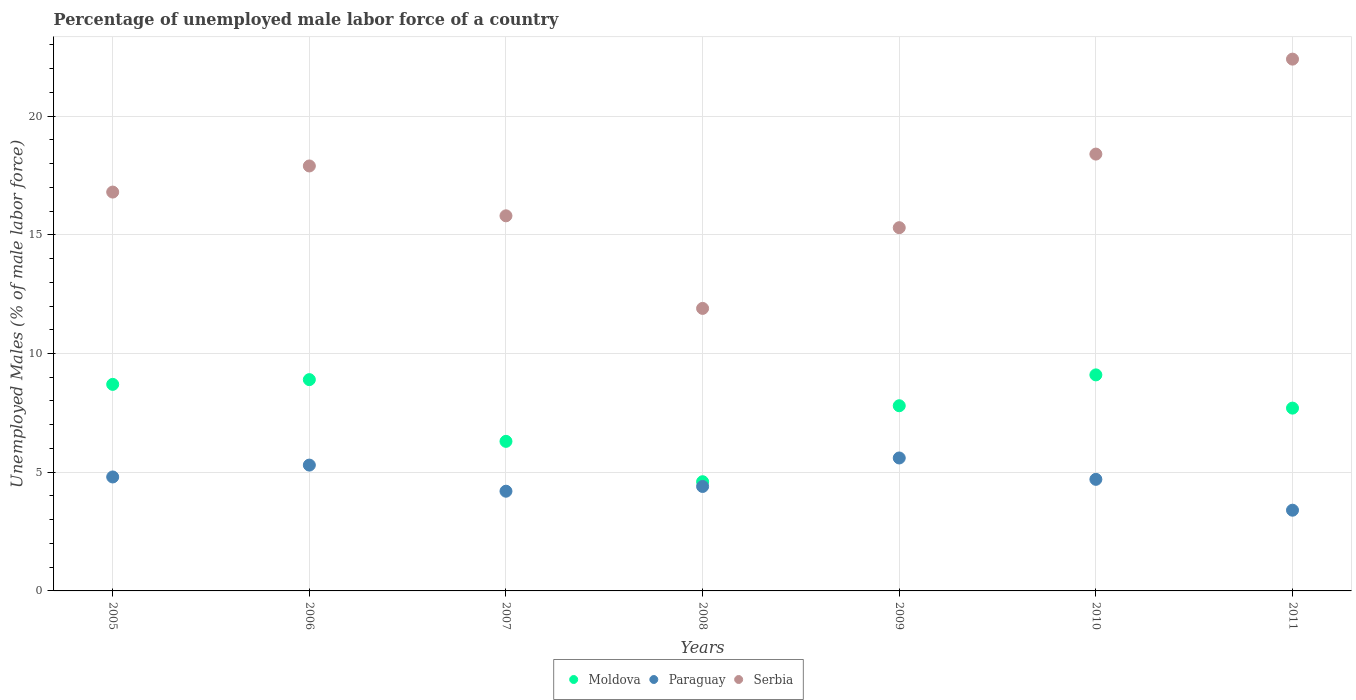Is the number of dotlines equal to the number of legend labels?
Ensure brevity in your answer.  Yes. What is the percentage of unemployed male labor force in Paraguay in 2007?
Make the answer very short. 4.2. Across all years, what is the maximum percentage of unemployed male labor force in Moldova?
Provide a short and direct response. 9.1. Across all years, what is the minimum percentage of unemployed male labor force in Serbia?
Ensure brevity in your answer.  11.9. In which year was the percentage of unemployed male labor force in Paraguay maximum?
Provide a short and direct response. 2009. In which year was the percentage of unemployed male labor force in Serbia minimum?
Make the answer very short. 2008. What is the total percentage of unemployed male labor force in Moldova in the graph?
Offer a very short reply. 53.1. What is the difference between the percentage of unemployed male labor force in Serbia in 2009 and that in 2011?
Your answer should be compact. -7.1. What is the difference between the percentage of unemployed male labor force in Paraguay in 2011 and the percentage of unemployed male labor force in Serbia in 2005?
Keep it short and to the point. -13.4. What is the average percentage of unemployed male labor force in Paraguay per year?
Offer a very short reply. 4.63. In the year 2010, what is the difference between the percentage of unemployed male labor force in Serbia and percentage of unemployed male labor force in Moldova?
Offer a terse response. 9.3. What is the ratio of the percentage of unemployed male labor force in Paraguay in 2008 to that in 2011?
Your answer should be very brief. 1.29. What is the difference between the highest and the second highest percentage of unemployed male labor force in Moldova?
Provide a short and direct response. 0.2. What is the difference between the highest and the lowest percentage of unemployed male labor force in Moldova?
Make the answer very short. 4.5. Is the sum of the percentage of unemployed male labor force in Paraguay in 2009 and 2011 greater than the maximum percentage of unemployed male labor force in Moldova across all years?
Offer a terse response. No. Is it the case that in every year, the sum of the percentage of unemployed male labor force in Serbia and percentage of unemployed male labor force in Moldova  is greater than the percentage of unemployed male labor force in Paraguay?
Your answer should be very brief. Yes. Does the percentage of unemployed male labor force in Serbia monotonically increase over the years?
Offer a very short reply. No. What is the difference between two consecutive major ticks on the Y-axis?
Give a very brief answer. 5. Does the graph contain grids?
Keep it short and to the point. Yes. How many legend labels are there?
Keep it short and to the point. 3. What is the title of the graph?
Provide a short and direct response. Percentage of unemployed male labor force of a country. Does "North America" appear as one of the legend labels in the graph?
Ensure brevity in your answer.  No. What is the label or title of the X-axis?
Keep it short and to the point. Years. What is the label or title of the Y-axis?
Keep it short and to the point. Unemployed Males (% of male labor force). What is the Unemployed Males (% of male labor force) in Moldova in 2005?
Your answer should be compact. 8.7. What is the Unemployed Males (% of male labor force) of Paraguay in 2005?
Your response must be concise. 4.8. What is the Unemployed Males (% of male labor force) of Serbia in 2005?
Ensure brevity in your answer.  16.8. What is the Unemployed Males (% of male labor force) in Moldova in 2006?
Make the answer very short. 8.9. What is the Unemployed Males (% of male labor force) in Paraguay in 2006?
Ensure brevity in your answer.  5.3. What is the Unemployed Males (% of male labor force) in Serbia in 2006?
Provide a short and direct response. 17.9. What is the Unemployed Males (% of male labor force) of Moldova in 2007?
Provide a succinct answer. 6.3. What is the Unemployed Males (% of male labor force) in Paraguay in 2007?
Offer a terse response. 4.2. What is the Unemployed Males (% of male labor force) in Serbia in 2007?
Provide a short and direct response. 15.8. What is the Unemployed Males (% of male labor force) in Moldova in 2008?
Your answer should be very brief. 4.6. What is the Unemployed Males (% of male labor force) of Paraguay in 2008?
Provide a succinct answer. 4.4. What is the Unemployed Males (% of male labor force) in Serbia in 2008?
Ensure brevity in your answer.  11.9. What is the Unemployed Males (% of male labor force) of Moldova in 2009?
Your answer should be very brief. 7.8. What is the Unemployed Males (% of male labor force) of Paraguay in 2009?
Keep it short and to the point. 5.6. What is the Unemployed Males (% of male labor force) of Serbia in 2009?
Give a very brief answer. 15.3. What is the Unemployed Males (% of male labor force) in Moldova in 2010?
Offer a very short reply. 9.1. What is the Unemployed Males (% of male labor force) of Paraguay in 2010?
Give a very brief answer. 4.7. What is the Unemployed Males (% of male labor force) of Serbia in 2010?
Your response must be concise. 18.4. What is the Unemployed Males (% of male labor force) in Moldova in 2011?
Ensure brevity in your answer.  7.7. What is the Unemployed Males (% of male labor force) in Paraguay in 2011?
Provide a short and direct response. 3.4. What is the Unemployed Males (% of male labor force) of Serbia in 2011?
Provide a short and direct response. 22.4. Across all years, what is the maximum Unemployed Males (% of male labor force) of Moldova?
Offer a very short reply. 9.1. Across all years, what is the maximum Unemployed Males (% of male labor force) in Paraguay?
Keep it short and to the point. 5.6. Across all years, what is the maximum Unemployed Males (% of male labor force) of Serbia?
Your response must be concise. 22.4. Across all years, what is the minimum Unemployed Males (% of male labor force) of Moldova?
Your answer should be very brief. 4.6. Across all years, what is the minimum Unemployed Males (% of male labor force) of Paraguay?
Provide a short and direct response. 3.4. Across all years, what is the minimum Unemployed Males (% of male labor force) in Serbia?
Give a very brief answer. 11.9. What is the total Unemployed Males (% of male labor force) of Moldova in the graph?
Keep it short and to the point. 53.1. What is the total Unemployed Males (% of male labor force) in Paraguay in the graph?
Keep it short and to the point. 32.4. What is the total Unemployed Males (% of male labor force) of Serbia in the graph?
Offer a terse response. 118.5. What is the difference between the Unemployed Males (% of male labor force) of Paraguay in 2005 and that in 2007?
Your answer should be compact. 0.6. What is the difference between the Unemployed Males (% of male labor force) in Paraguay in 2005 and that in 2008?
Offer a terse response. 0.4. What is the difference between the Unemployed Males (% of male labor force) in Moldova in 2005 and that in 2009?
Give a very brief answer. 0.9. What is the difference between the Unemployed Males (% of male labor force) in Serbia in 2005 and that in 2009?
Provide a short and direct response. 1.5. What is the difference between the Unemployed Males (% of male labor force) of Paraguay in 2005 and that in 2010?
Offer a terse response. 0.1. What is the difference between the Unemployed Males (% of male labor force) in Serbia in 2005 and that in 2010?
Provide a succinct answer. -1.6. What is the difference between the Unemployed Males (% of male labor force) in Moldova in 2005 and that in 2011?
Your response must be concise. 1. What is the difference between the Unemployed Males (% of male labor force) in Paraguay in 2005 and that in 2011?
Your answer should be compact. 1.4. What is the difference between the Unemployed Males (% of male labor force) in Serbia in 2005 and that in 2011?
Your answer should be very brief. -5.6. What is the difference between the Unemployed Males (% of male labor force) of Moldova in 2006 and that in 2007?
Provide a succinct answer. 2.6. What is the difference between the Unemployed Males (% of male labor force) of Paraguay in 2006 and that in 2007?
Your response must be concise. 1.1. What is the difference between the Unemployed Males (% of male labor force) in Moldova in 2006 and that in 2008?
Your answer should be compact. 4.3. What is the difference between the Unemployed Males (% of male labor force) in Serbia in 2006 and that in 2008?
Give a very brief answer. 6. What is the difference between the Unemployed Males (% of male labor force) in Moldova in 2006 and that in 2009?
Give a very brief answer. 1.1. What is the difference between the Unemployed Males (% of male labor force) in Moldova in 2006 and that in 2010?
Your answer should be very brief. -0.2. What is the difference between the Unemployed Males (% of male labor force) of Paraguay in 2006 and that in 2010?
Make the answer very short. 0.6. What is the difference between the Unemployed Males (% of male labor force) in Serbia in 2006 and that in 2011?
Offer a very short reply. -4.5. What is the difference between the Unemployed Males (% of male labor force) of Moldova in 2007 and that in 2009?
Ensure brevity in your answer.  -1.5. What is the difference between the Unemployed Males (% of male labor force) in Paraguay in 2007 and that in 2009?
Your answer should be compact. -1.4. What is the difference between the Unemployed Males (% of male labor force) in Moldova in 2007 and that in 2010?
Provide a succinct answer. -2.8. What is the difference between the Unemployed Males (% of male labor force) of Serbia in 2007 and that in 2010?
Your answer should be compact. -2.6. What is the difference between the Unemployed Males (% of male labor force) in Paraguay in 2007 and that in 2011?
Offer a terse response. 0.8. What is the difference between the Unemployed Males (% of male labor force) of Serbia in 2007 and that in 2011?
Provide a short and direct response. -6.6. What is the difference between the Unemployed Males (% of male labor force) of Paraguay in 2008 and that in 2009?
Your answer should be compact. -1.2. What is the difference between the Unemployed Males (% of male labor force) of Moldova in 2008 and that in 2010?
Provide a short and direct response. -4.5. What is the difference between the Unemployed Males (% of male labor force) in Paraguay in 2008 and that in 2010?
Your answer should be very brief. -0.3. What is the difference between the Unemployed Males (% of male labor force) in Serbia in 2008 and that in 2010?
Provide a short and direct response. -6.5. What is the difference between the Unemployed Males (% of male labor force) of Paraguay in 2008 and that in 2011?
Your answer should be compact. 1. What is the difference between the Unemployed Males (% of male labor force) in Serbia in 2008 and that in 2011?
Your answer should be very brief. -10.5. What is the difference between the Unemployed Males (% of male labor force) of Moldova in 2009 and that in 2010?
Give a very brief answer. -1.3. What is the difference between the Unemployed Males (% of male labor force) of Paraguay in 2009 and that in 2010?
Your response must be concise. 0.9. What is the difference between the Unemployed Males (% of male labor force) of Paraguay in 2009 and that in 2011?
Your response must be concise. 2.2. What is the difference between the Unemployed Males (% of male labor force) in Serbia in 2009 and that in 2011?
Ensure brevity in your answer.  -7.1. What is the difference between the Unemployed Males (% of male labor force) of Moldova in 2010 and that in 2011?
Provide a short and direct response. 1.4. What is the difference between the Unemployed Males (% of male labor force) in Paraguay in 2010 and that in 2011?
Make the answer very short. 1.3. What is the difference between the Unemployed Males (% of male labor force) of Serbia in 2010 and that in 2011?
Give a very brief answer. -4. What is the difference between the Unemployed Males (% of male labor force) of Moldova in 2005 and the Unemployed Males (% of male labor force) of Paraguay in 2006?
Offer a terse response. 3.4. What is the difference between the Unemployed Males (% of male labor force) of Moldova in 2005 and the Unemployed Males (% of male labor force) of Serbia in 2006?
Your response must be concise. -9.2. What is the difference between the Unemployed Males (% of male labor force) in Paraguay in 2005 and the Unemployed Males (% of male labor force) in Serbia in 2006?
Your answer should be compact. -13.1. What is the difference between the Unemployed Males (% of male labor force) of Moldova in 2005 and the Unemployed Males (% of male labor force) of Serbia in 2007?
Provide a succinct answer. -7.1. What is the difference between the Unemployed Males (% of male labor force) in Paraguay in 2005 and the Unemployed Males (% of male labor force) in Serbia in 2007?
Make the answer very short. -11. What is the difference between the Unemployed Males (% of male labor force) of Moldova in 2005 and the Unemployed Males (% of male labor force) of Paraguay in 2008?
Provide a short and direct response. 4.3. What is the difference between the Unemployed Males (% of male labor force) in Moldova in 2005 and the Unemployed Males (% of male labor force) in Paraguay in 2009?
Offer a very short reply. 3.1. What is the difference between the Unemployed Males (% of male labor force) of Moldova in 2005 and the Unemployed Males (% of male labor force) of Serbia in 2009?
Make the answer very short. -6.6. What is the difference between the Unemployed Males (% of male labor force) of Paraguay in 2005 and the Unemployed Males (% of male labor force) of Serbia in 2009?
Your response must be concise. -10.5. What is the difference between the Unemployed Males (% of male labor force) in Moldova in 2005 and the Unemployed Males (% of male labor force) in Serbia in 2010?
Give a very brief answer. -9.7. What is the difference between the Unemployed Males (% of male labor force) in Paraguay in 2005 and the Unemployed Males (% of male labor force) in Serbia in 2010?
Your response must be concise. -13.6. What is the difference between the Unemployed Males (% of male labor force) of Moldova in 2005 and the Unemployed Males (% of male labor force) of Serbia in 2011?
Offer a terse response. -13.7. What is the difference between the Unemployed Males (% of male labor force) in Paraguay in 2005 and the Unemployed Males (% of male labor force) in Serbia in 2011?
Your answer should be very brief. -17.6. What is the difference between the Unemployed Males (% of male labor force) in Moldova in 2006 and the Unemployed Males (% of male labor force) in Serbia in 2007?
Keep it short and to the point. -6.9. What is the difference between the Unemployed Males (% of male labor force) in Moldova in 2006 and the Unemployed Males (% of male labor force) in Paraguay in 2008?
Offer a very short reply. 4.5. What is the difference between the Unemployed Males (% of male labor force) of Moldova in 2006 and the Unemployed Males (% of male labor force) of Serbia in 2008?
Offer a terse response. -3. What is the difference between the Unemployed Males (% of male labor force) of Paraguay in 2006 and the Unemployed Males (% of male labor force) of Serbia in 2008?
Ensure brevity in your answer.  -6.6. What is the difference between the Unemployed Males (% of male labor force) of Moldova in 2006 and the Unemployed Males (% of male labor force) of Paraguay in 2009?
Your answer should be very brief. 3.3. What is the difference between the Unemployed Males (% of male labor force) of Paraguay in 2006 and the Unemployed Males (% of male labor force) of Serbia in 2010?
Your response must be concise. -13.1. What is the difference between the Unemployed Males (% of male labor force) of Moldova in 2006 and the Unemployed Males (% of male labor force) of Paraguay in 2011?
Your answer should be compact. 5.5. What is the difference between the Unemployed Males (% of male labor force) in Paraguay in 2006 and the Unemployed Males (% of male labor force) in Serbia in 2011?
Offer a terse response. -17.1. What is the difference between the Unemployed Males (% of male labor force) of Moldova in 2007 and the Unemployed Males (% of male labor force) of Serbia in 2008?
Your answer should be very brief. -5.6. What is the difference between the Unemployed Males (% of male labor force) of Paraguay in 2007 and the Unemployed Males (% of male labor force) of Serbia in 2009?
Your response must be concise. -11.1. What is the difference between the Unemployed Males (% of male labor force) in Moldova in 2007 and the Unemployed Males (% of male labor force) in Paraguay in 2010?
Your answer should be very brief. 1.6. What is the difference between the Unemployed Males (% of male labor force) in Moldova in 2007 and the Unemployed Males (% of male labor force) in Serbia in 2011?
Provide a succinct answer. -16.1. What is the difference between the Unemployed Males (% of male labor force) of Paraguay in 2007 and the Unemployed Males (% of male labor force) of Serbia in 2011?
Provide a succinct answer. -18.2. What is the difference between the Unemployed Males (% of male labor force) of Moldova in 2008 and the Unemployed Males (% of male labor force) of Paraguay in 2009?
Ensure brevity in your answer.  -1. What is the difference between the Unemployed Males (% of male labor force) of Paraguay in 2008 and the Unemployed Males (% of male labor force) of Serbia in 2009?
Give a very brief answer. -10.9. What is the difference between the Unemployed Males (% of male labor force) in Moldova in 2008 and the Unemployed Males (% of male labor force) in Serbia in 2010?
Give a very brief answer. -13.8. What is the difference between the Unemployed Males (% of male labor force) of Moldova in 2008 and the Unemployed Males (% of male labor force) of Serbia in 2011?
Provide a short and direct response. -17.8. What is the difference between the Unemployed Males (% of male labor force) of Paraguay in 2008 and the Unemployed Males (% of male labor force) of Serbia in 2011?
Ensure brevity in your answer.  -18. What is the difference between the Unemployed Males (% of male labor force) of Moldova in 2009 and the Unemployed Males (% of male labor force) of Paraguay in 2010?
Make the answer very short. 3.1. What is the difference between the Unemployed Males (% of male labor force) in Paraguay in 2009 and the Unemployed Males (% of male labor force) in Serbia in 2010?
Ensure brevity in your answer.  -12.8. What is the difference between the Unemployed Males (% of male labor force) in Moldova in 2009 and the Unemployed Males (% of male labor force) in Paraguay in 2011?
Ensure brevity in your answer.  4.4. What is the difference between the Unemployed Males (% of male labor force) in Moldova in 2009 and the Unemployed Males (% of male labor force) in Serbia in 2011?
Keep it short and to the point. -14.6. What is the difference between the Unemployed Males (% of male labor force) of Paraguay in 2009 and the Unemployed Males (% of male labor force) of Serbia in 2011?
Make the answer very short. -16.8. What is the difference between the Unemployed Males (% of male labor force) of Moldova in 2010 and the Unemployed Males (% of male labor force) of Paraguay in 2011?
Your response must be concise. 5.7. What is the difference between the Unemployed Males (% of male labor force) in Paraguay in 2010 and the Unemployed Males (% of male labor force) in Serbia in 2011?
Make the answer very short. -17.7. What is the average Unemployed Males (% of male labor force) of Moldova per year?
Your response must be concise. 7.59. What is the average Unemployed Males (% of male labor force) in Paraguay per year?
Your answer should be compact. 4.63. What is the average Unemployed Males (% of male labor force) of Serbia per year?
Offer a very short reply. 16.93. In the year 2005, what is the difference between the Unemployed Males (% of male labor force) of Moldova and Unemployed Males (% of male labor force) of Paraguay?
Keep it short and to the point. 3.9. In the year 2005, what is the difference between the Unemployed Males (% of male labor force) of Moldova and Unemployed Males (% of male labor force) of Serbia?
Provide a succinct answer. -8.1. In the year 2006, what is the difference between the Unemployed Males (% of male labor force) in Moldova and Unemployed Males (% of male labor force) in Serbia?
Offer a very short reply. -9. In the year 2007, what is the difference between the Unemployed Males (% of male labor force) in Moldova and Unemployed Males (% of male labor force) in Paraguay?
Offer a terse response. 2.1. In the year 2008, what is the difference between the Unemployed Males (% of male labor force) of Moldova and Unemployed Males (% of male labor force) of Paraguay?
Offer a very short reply. 0.2. In the year 2009, what is the difference between the Unemployed Males (% of male labor force) in Moldova and Unemployed Males (% of male labor force) in Serbia?
Your answer should be very brief. -7.5. In the year 2010, what is the difference between the Unemployed Males (% of male labor force) of Moldova and Unemployed Males (% of male labor force) of Serbia?
Make the answer very short. -9.3. In the year 2010, what is the difference between the Unemployed Males (% of male labor force) in Paraguay and Unemployed Males (% of male labor force) in Serbia?
Offer a terse response. -13.7. In the year 2011, what is the difference between the Unemployed Males (% of male labor force) in Moldova and Unemployed Males (% of male labor force) in Serbia?
Your response must be concise. -14.7. What is the ratio of the Unemployed Males (% of male labor force) of Moldova in 2005 to that in 2006?
Provide a succinct answer. 0.98. What is the ratio of the Unemployed Males (% of male labor force) of Paraguay in 2005 to that in 2006?
Offer a very short reply. 0.91. What is the ratio of the Unemployed Males (% of male labor force) of Serbia in 2005 to that in 2006?
Give a very brief answer. 0.94. What is the ratio of the Unemployed Males (% of male labor force) of Moldova in 2005 to that in 2007?
Give a very brief answer. 1.38. What is the ratio of the Unemployed Males (% of male labor force) of Serbia in 2005 to that in 2007?
Keep it short and to the point. 1.06. What is the ratio of the Unemployed Males (% of male labor force) in Moldova in 2005 to that in 2008?
Offer a very short reply. 1.89. What is the ratio of the Unemployed Males (% of male labor force) of Paraguay in 2005 to that in 2008?
Offer a terse response. 1.09. What is the ratio of the Unemployed Males (% of male labor force) in Serbia in 2005 to that in 2008?
Your answer should be compact. 1.41. What is the ratio of the Unemployed Males (% of male labor force) in Moldova in 2005 to that in 2009?
Make the answer very short. 1.12. What is the ratio of the Unemployed Males (% of male labor force) in Serbia in 2005 to that in 2009?
Your response must be concise. 1.1. What is the ratio of the Unemployed Males (% of male labor force) in Moldova in 2005 to that in 2010?
Give a very brief answer. 0.96. What is the ratio of the Unemployed Males (% of male labor force) of Paraguay in 2005 to that in 2010?
Offer a very short reply. 1.02. What is the ratio of the Unemployed Males (% of male labor force) in Moldova in 2005 to that in 2011?
Your answer should be compact. 1.13. What is the ratio of the Unemployed Males (% of male labor force) of Paraguay in 2005 to that in 2011?
Offer a terse response. 1.41. What is the ratio of the Unemployed Males (% of male labor force) in Moldova in 2006 to that in 2007?
Give a very brief answer. 1.41. What is the ratio of the Unemployed Males (% of male labor force) of Paraguay in 2006 to that in 2007?
Keep it short and to the point. 1.26. What is the ratio of the Unemployed Males (% of male labor force) in Serbia in 2006 to that in 2007?
Your answer should be very brief. 1.13. What is the ratio of the Unemployed Males (% of male labor force) of Moldova in 2006 to that in 2008?
Your answer should be compact. 1.93. What is the ratio of the Unemployed Males (% of male labor force) of Paraguay in 2006 to that in 2008?
Ensure brevity in your answer.  1.2. What is the ratio of the Unemployed Males (% of male labor force) in Serbia in 2006 to that in 2008?
Provide a succinct answer. 1.5. What is the ratio of the Unemployed Males (% of male labor force) of Moldova in 2006 to that in 2009?
Provide a succinct answer. 1.14. What is the ratio of the Unemployed Males (% of male labor force) of Paraguay in 2006 to that in 2009?
Your answer should be very brief. 0.95. What is the ratio of the Unemployed Males (% of male labor force) in Serbia in 2006 to that in 2009?
Keep it short and to the point. 1.17. What is the ratio of the Unemployed Males (% of male labor force) in Moldova in 2006 to that in 2010?
Your answer should be very brief. 0.98. What is the ratio of the Unemployed Males (% of male labor force) in Paraguay in 2006 to that in 2010?
Offer a very short reply. 1.13. What is the ratio of the Unemployed Males (% of male labor force) of Serbia in 2006 to that in 2010?
Offer a terse response. 0.97. What is the ratio of the Unemployed Males (% of male labor force) in Moldova in 2006 to that in 2011?
Offer a terse response. 1.16. What is the ratio of the Unemployed Males (% of male labor force) of Paraguay in 2006 to that in 2011?
Your response must be concise. 1.56. What is the ratio of the Unemployed Males (% of male labor force) of Serbia in 2006 to that in 2011?
Give a very brief answer. 0.8. What is the ratio of the Unemployed Males (% of male labor force) of Moldova in 2007 to that in 2008?
Make the answer very short. 1.37. What is the ratio of the Unemployed Males (% of male labor force) of Paraguay in 2007 to that in 2008?
Provide a short and direct response. 0.95. What is the ratio of the Unemployed Males (% of male labor force) in Serbia in 2007 to that in 2008?
Ensure brevity in your answer.  1.33. What is the ratio of the Unemployed Males (% of male labor force) in Moldova in 2007 to that in 2009?
Your response must be concise. 0.81. What is the ratio of the Unemployed Males (% of male labor force) of Paraguay in 2007 to that in 2009?
Offer a terse response. 0.75. What is the ratio of the Unemployed Males (% of male labor force) of Serbia in 2007 to that in 2009?
Offer a terse response. 1.03. What is the ratio of the Unemployed Males (% of male labor force) in Moldova in 2007 to that in 2010?
Provide a short and direct response. 0.69. What is the ratio of the Unemployed Males (% of male labor force) in Paraguay in 2007 to that in 2010?
Ensure brevity in your answer.  0.89. What is the ratio of the Unemployed Males (% of male labor force) in Serbia in 2007 to that in 2010?
Your answer should be compact. 0.86. What is the ratio of the Unemployed Males (% of male labor force) in Moldova in 2007 to that in 2011?
Provide a short and direct response. 0.82. What is the ratio of the Unemployed Males (% of male labor force) of Paraguay in 2007 to that in 2011?
Offer a terse response. 1.24. What is the ratio of the Unemployed Males (% of male labor force) of Serbia in 2007 to that in 2011?
Offer a very short reply. 0.71. What is the ratio of the Unemployed Males (% of male labor force) in Moldova in 2008 to that in 2009?
Provide a succinct answer. 0.59. What is the ratio of the Unemployed Males (% of male labor force) in Paraguay in 2008 to that in 2009?
Provide a succinct answer. 0.79. What is the ratio of the Unemployed Males (% of male labor force) of Moldova in 2008 to that in 2010?
Keep it short and to the point. 0.51. What is the ratio of the Unemployed Males (% of male labor force) of Paraguay in 2008 to that in 2010?
Provide a succinct answer. 0.94. What is the ratio of the Unemployed Males (% of male labor force) of Serbia in 2008 to that in 2010?
Offer a terse response. 0.65. What is the ratio of the Unemployed Males (% of male labor force) in Moldova in 2008 to that in 2011?
Ensure brevity in your answer.  0.6. What is the ratio of the Unemployed Males (% of male labor force) in Paraguay in 2008 to that in 2011?
Ensure brevity in your answer.  1.29. What is the ratio of the Unemployed Males (% of male labor force) in Serbia in 2008 to that in 2011?
Offer a terse response. 0.53. What is the ratio of the Unemployed Males (% of male labor force) of Paraguay in 2009 to that in 2010?
Your response must be concise. 1.19. What is the ratio of the Unemployed Males (% of male labor force) in Serbia in 2009 to that in 2010?
Keep it short and to the point. 0.83. What is the ratio of the Unemployed Males (% of male labor force) in Paraguay in 2009 to that in 2011?
Offer a terse response. 1.65. What is the ratio of the Unemployed Males (% of male labor force) in Serbia in 2009 to that in 2011?
Offer a very short reply. 0.68. What is the ratio of the Unemployed Males (% of male labor force) of Moldova in 2010 to that in 2011?
Provide a short and direct response. 1.18. What is the ratio of the Unemployed Males (% of male labor force) of Paraguay in 2010 to that in 2011?
Your answer should be very brief. 1.38. What is the ratio of the Unemployed Males (% of male labor force) of Serbia in 2010 to that in 2011?
Ensure brevity in your answer.  0.82. 